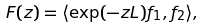Convert formula to latex. <formula><loc_0><loc_0><loc_500><loc_500>F ( z ) = \langle \exp ( - z L ) f _ { 1 } , f _ { 2 } \rangle ,</formula> 